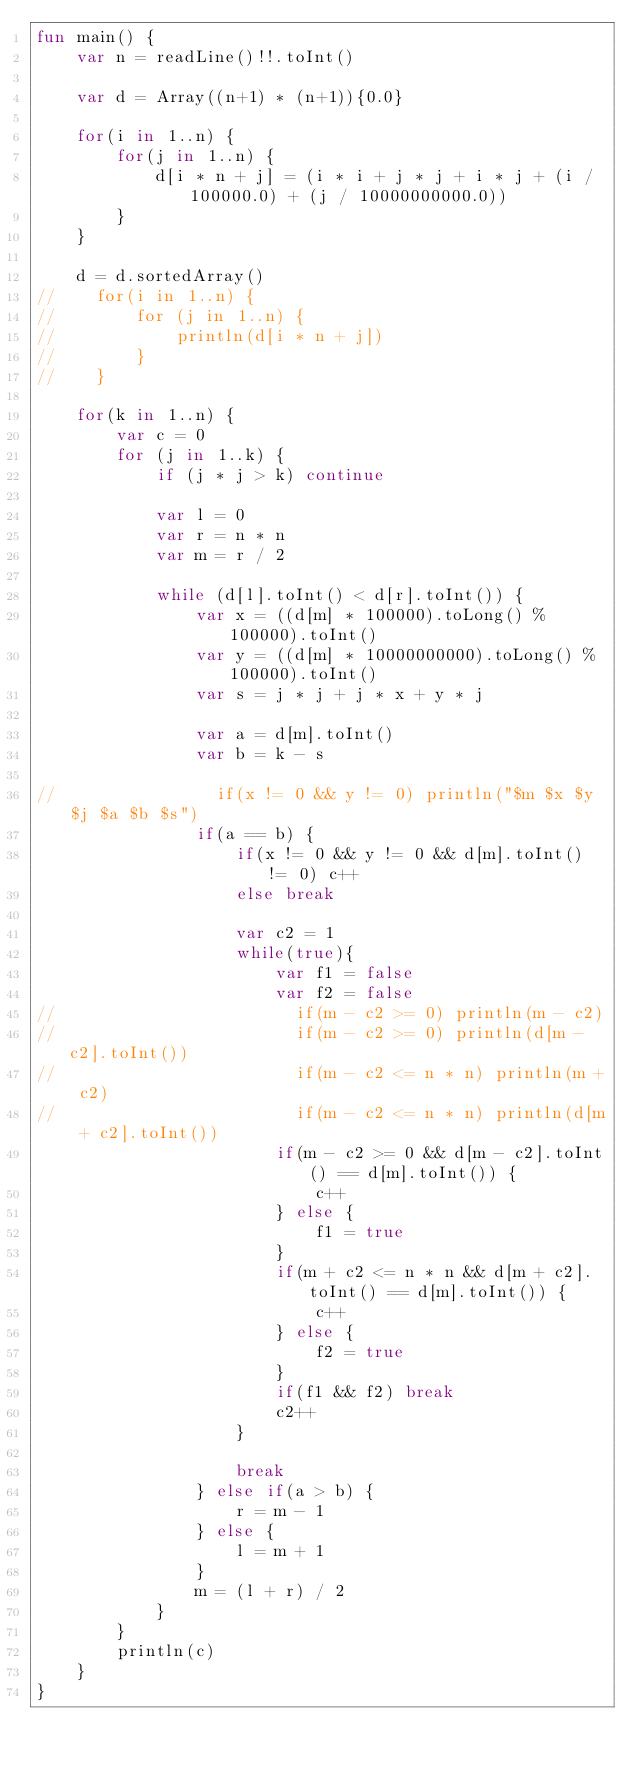<code> <loc_0><loc_0><loc_500><loc_500><_Kotlin_>fun main() {
    var n = readLine()!!.toInt()

    var d = Array((n+1) * (n+1)){0.0}

    for(i in 1..n) {
        for(j in 1..n) {
            d[i * n + j] = (i * i + j * j + i * j + (i / 100000.0) + (j / 10000000000.0))
        }
    }

    d = d.sortedArray()
//    for(i in 1..n) {
//        for (j in 1..n) {
//            println(d[i * n + j])
//        }
//    }

    for(k in 1..n) {
        var c = 0
        for (j in 1..k) {
            if (j * j > k) continue

            var l = 0
            var r = n * n
            var m = r / 2

            while (d[l].toInt() < d[r].toInt()) {
                var x = ((d[m] * 100000).toLong() % 100000).toInt()
                var y = ((d[m] * 10000000000).toLong() % 100000).toInt()
                var s = j * j + j * x + y * j

                var a = d[m].toInt()
                var b = k - s

//                if(x != 0 && y != 0) println("$m $x $y $j $a $b $s")
                if(a == b) {
                    if(x != 0 && y != 0 && d[m].toInt() != 0) c++
                    else break

                    var c2 = 1
                    while(true){
                        var f1 = false
                        var f2 = false
//                        if(m - c2 >= 0) println(m - c2)
//                        if(m - c2 >= 0) println(d[m - c2].toInt())
//                        if(m - c2 <= n * n) println(m + c2)
//                        if(m - c2 <= n * n) println(d[m + c2].toInt())
                        if(m - c2 >= 0 && d[m - c2].toInt() == d[m].toInt()) {
                            c++
                        } else {
                            f1 = true
                        }
                        if(m + c2 <= n * n && d[m + c2].toInt() == d[m].toInt()) {
                            c++
                        } else {
                            f2 = true
                        }
                        if(f1 && f2) break
                        c2++
                    }

                    break
                } else if(a > b) {
                    r = m - 1
                } else {
                    l = m + 1
                }
                m = (l + r) / 2
            }
        }
        println(c)
    }
}</code> 